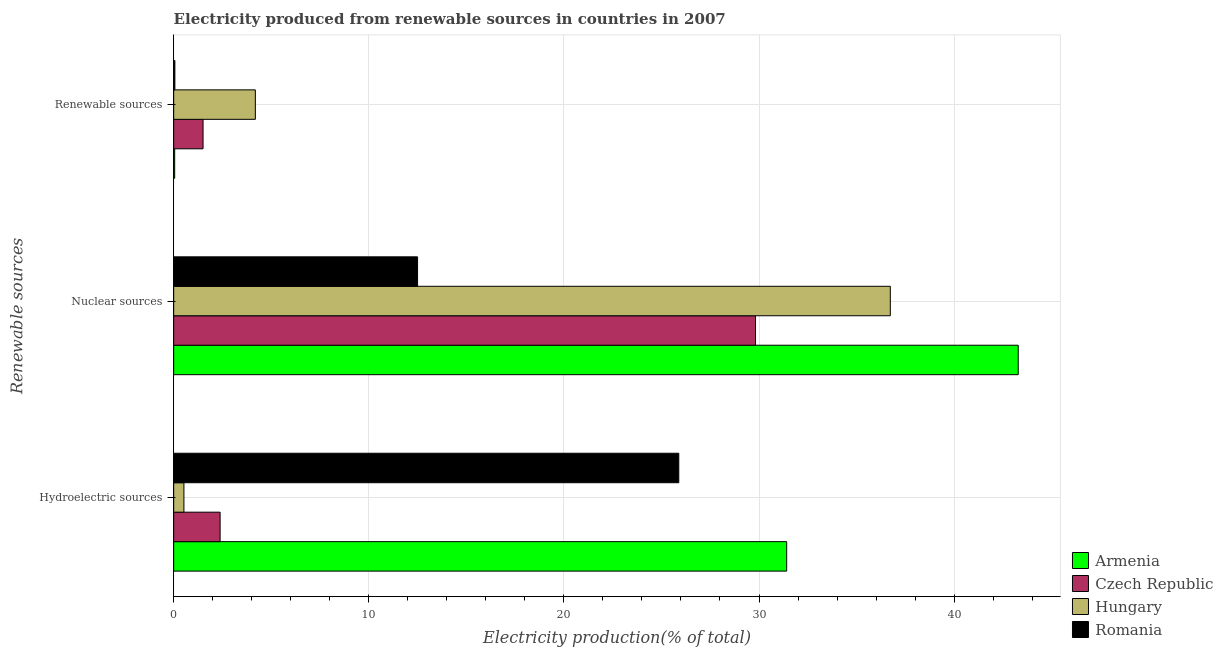How many different coloured bars are there?
Your answer should be compact. 4. How many groups of bars are there?
Your response must be concise. 3. Are the number of bars per tick equal to the number of legend labels?
Ensure brevity in your answer.  Yes. How many bars are there on the 2nd tick from the top?
Your answer should be compact. 4. What is the label of the 1st group of bars from the top?
Your response must be concise. Renewable sources. What is the percentage of electricity produced by renewable sources in Armenia?
Offer a terse response. 0.05. Across all countries, what is the maximum percentage of electricity produced by renewable sources?
Your answer should be very brief. 4.19. Across all countries, what is the minimum percentage of electricity produced by hydroelectric sources?
Your answer should be very brief. 0.53. In which country was the percentage of electricity produced by renewable sources maximum?
Offer a terse response. Hungary. In which country was the percentage of electricity produced by nuclear sources minimum?
Give a very brief answer. Romania. What is the total percentage of electricity produced by renewable sources in the graph?
Your answer should be very brief. 5.8. What is the difference between the percentage of electricity produced by renewable sources in Hungary and that in Romania?
Your answer should be compact. 4.13. What is the difference between the percentage of electricity produced by renewable sources in Romania and the percentage of electricity produced by hydroelectric sources in Armenia?
Keep it short and to the point. -31.36. What is the average percentage of electricity produced by renewable sources per country?
Ensure brevity in your answer.  1.45. What is the difference between the percentage of electricity produced by hydroelectric sources and percentage of electricity produced by nuclear sources in Armenia?
Your answer should be compact. -11.87. What is the ratio of the percentage of electricity produced by hydroelectric sources in Hungary to that in Czech Republic?
Your response must be concise. 0.22. Is the percentage of electricity produced by nuclear sources in Armenia less than that in Hungary?
Offer a terse response. No. Is the difference between the percentage of electricity produced by nuclear sources in Hungary and Armenia greater than the difference between the percentage of electricity produced by hydroelectric sources in Hungary and Armenia?
Your answer should be compact. Yes. What is the difference between the highest and the second highest percentage of electricity produced by nuclear sources?
Make the answer very short. 6.56. What is the difference between the highest and the lowest percentage of electricity produced by renewable sources?
Offer a terse response. 4.14. What does the 2nd bar from the top in Renewable sources represents?
Keep it short and to the point. Hungary. What does the 2nd bar from the bottom in Renewable sources represents?
Offer a terse response. Czech Republic. Is it the case that in every country, the sum of the percentage of electricity produced by hydroelectric sources and percentage of electricity produced by nuclear sources is greater than the percentage of electricity produced by renewable sources?
Offer a terse response. Yes. How many bars are there?
Provide a succinct answer. 12. Are all the bars in the graph horizontal?
Keep it short and to the point. Yes. Are the values on the major ticks of X-axis written in scientific E-notation?
Your answer should be very brief. No. Does the graph contain grids?
Your answer should be very brief. Yes. Where does the legend appear in the graph?
Make the answer very short. Bottom right. How many legend labels are there?
Your response must be concise. 4. How are the legend labels stacked?
Provide a short and direct response. Vertical. What is the title of the graph?
Make the answer very short. Electricity produced from renewable sources in countries in 2007. Does "Bhutan" appear as one of the legend labels in the graph?
Provide a succinct answer. No. What is the label or title of the X-axis?
Offer a very short reply. Electricity production(% of total). What is the label or title of the Y-axis?
Your answer should be very brief. Renewable sources. What is the Electricity production(% of total) of Armenia in Hydroelectric sources?
Ensure brevity in your answer.  31.42. What is the Electricity production(% of total) in Czech Republic in Hydroelectric sources?
Offer a very short reply. 2.38. What is the Electricity production(% of total) of Hungary in Hydroelectric sources?
Your answer should be very brief. 0.53. What is the Electricity production(% of total) in Romania in Hydroelectric sources?
Give a very brief answer. 25.89. What is the Electricity production(% of total) in Armenia in Nuclear sources?
Keep it short and to the point. 43.29. What is the Electricity production(% of total) in Czech Republic in Nuclear sources?
Give a very brief answer. 29.82. What is the Electricity production(% of total) of Hungary in Nuclear sources?
Your response must be concise. 36.73. What is the Electricity production(% of total) of Romania in Nuclear sources?
Offer a terse response. 12.5. What is the Electricity production(% of total) of Armenia in Renewable sources?
Offer a terse response. 0.05. What is the Electricity production(% of total) of Czech Republic in Renewable sources?
Provide a short and direct response. 1.51. What is the Electricity production(% of total) in Hungary in Renewable sources?
Your response must be concise. 4.19. What is the Electricity production(% of total) of Romania in Renewable sources?
Your answer should be compact. 0.06. Across all Renewable sources, what is the maximum Electricity production(% of total) in Armenia?
Make the answer very short. 43.29. Across all Renewable sources, what is the maximum Electricity production(% of total) in Czech Republic?
Ensure brevity in your answer.  29.82. Across all Renewable sources, what is the maximum Electricity production(% of total) of Hungary?
Your answer should be compact. 36.73. Across all Renewable sources, what is the maximum Electricity production(% of total) in Romania?
Keep it short and to the point. 25.89. Across all Renewable sources, what is the minimum Electricity production(% of total) in Armenia?
Ensure brevity in your answer.  0.05. Across all Renewable sources, what is the minimum Electricity production(% of total) in Czech Republic?
Offer a very short reply. 1.51. Across all Renewable sources, what is the minimum Electricity production(% of total) of Hungary?
Ensure brevity in your answer.  0.53. Across all Renewable sources, what is the minimum Electricity production(% of total) of Romania?
Your response must be concise. 0.06. What is the total Electricity production(% of total) of Armenia in the graph?
Provide a short and direct response. 74.75. What is the total Electricity production(% of total) in Czech Republic in the graph?
Offer a very short reply. 33.71. What is the total Electricity production(% of total) of Hungary in the graph?
Offer a terse response. 41.44. What is the total Electricity production(% of total) of Romania in the graph?
Offer a very short reply. 38.45. What is the difference between the Electricity production(% of total) in Armenia in Hydroelectric sources and that in Nuclear sources?
Offer a terse response. -11.87. What is the difference between the Electricity production(% of total) of Czech Republic in Hydroelectric sources and that in Nuclear sources?
Provide a short and direct response. -27.44. What is the difference between the Electricity production(% of total) in Hungary in Hydroelectric sources and that in Nuclear sources?
Offer a very short reply. -36.2. What is the difference between the Electricity production(% of total) in Romania in Hydroelectric sources and that in Nuclear sources?
Make the answer very short. 13.39. What is the difference between the Electricity production(% of total) of Armenia in Hydroelectric sources and that in Renewable sources?
Keep it short and to the point. 31.37. What is the difference between the Electricity production(% of total) of Czech Republic in Hydroelectric sources and that in Renewable sources?
Provide a succinct answer. 0.88. What is the difference between the Electricity production(% of total) of Hungary in Hydroelectric sources and that in Renewable sources?
Your response must be concise. -3.66. What is the difference between the Electricity production(% of total) of Romania in Hydroelectric sources and that in Renewable sources?
Provide a succinct answer. 25.83. What is the difference between the Electricity production(% of total) of Armenia in Nuclear sources and that in Renewable sources?
Ensure brevity in your answer.  43.23. What is the difference between the Electricity production(% of total) of Czech Republic in Nuclear sources and that in Renewable sources?
Provide a short and direct response. 28.32. What is the difference between the Electricity production(% of total) in Hungary in Nuclear sources and that in Renewable sources?
Keep it short and to the point. 32.54. What is the difference between the Electricity production(% of total) in Romania in Nuclear sources and that in Renewable sources?
Offer a very short reply. 12.44. What is the difference between the Electricity production(% of total) in Armenia in Hydroelectric sources and the Electricity production(% of total) in Czech Republic in Nuclear sources?
Offer a very short reply. 1.6. What is the difference between the Electricity production(% of total) of Armenia in Hydroelectric sources and the Electricity production(% of total) of Hungary in Nuclear sources?
Offer a very short reply. -5.31. What is the difference between the Electricity production(% of total) of Armenia in Hydroelectric sources and the Electricity production(% of total) of Romania in Nuclear sources?
Provide a succinct answer. 18.92. What is the difference between the Electricity production(% of total) in Czech Republic in Hydroelectric sources and the Electricity production(% of total) in Hungary in Nuclear sources?
Provide a succinct answer. -34.35. What is the difference between the Electricity production(% of total) of Czech Republic in Hydroelectric sources and the Electricity production(% of total) of Romania in Nuclear sources?
Your answer should be compact. -10.12. What is the difference between the Electricity production(% of total) of Hungary in Hydroelectric sources and the Electricity production(% of total) of Romania in Nuclear sources?
Ensure brevity in your answer.  -11.97. What is the difference between the Electricity production(% of total) of Armenia in Hydroelectric sources and the Electricity production(% of total) of Czech Republic in Renewable sources?
Your answer should be compact. 29.91. What is the difference between the Electricity production(% of total) of Armenia in Hydroelectric sources and the Electricity production(% of total) of Hungary in Renewable sources?
Provide a succinct answer. 27.23. What is the difference between the Electricity production(% of total) of Armenia in Hydroelectric sources and the Electricity production(% of total) of Romania in Renewable sources?
Make the answer very short. 31.36. What is the difference between the Electricity production(% of total) of Czech Republic in Hydroelectric sources and the Electricity production(% of total) of Hungary in Renewable sources?
Give a very brief answer. -1.81. What is the difference between the Electricity production(% of total) of Czech Republic in Hydroelectric sources and the Electricity production(% of total) of Romania in Renewable sources?
Provide a short and direct response. 2.32. What is the difference between the Electricity production(% of total) in Hungary in Hydroelectric sources and the Electricity production(% of total) in Romania in Renewable sources?
Offer a terse response. 0.46. What is the difference between the Electricity production(% of total) of Armenia in Nuclear sources and the Electricity production(% of total) of Czech Republic in Renewable sources?
Keep it short and to the point. 41.78. What is the difference between the Electricity production(% of total) of Armenia in Nuclear sources and the Electricity production(% of total) of Hungary in Renewable sources?
Make the answer very short. 39.1. What is the difference between the Electricity production(% of total) of Armenia in Nuclear sources and the Electricity production(% of total) of Romania in Renewable sources?
Keep it short and to the point. 43.22. What is the difference between the Electricity production(% of total) of Czech Republic in Nuclear sources and the Electricity production(% of total) of Hungary in Renewable sources?
Keep it short and to the point. 25.63. What is the difference between the Electricity production(% of total) in Czech Republic in Nuclear sources and the Electricity production(% of total) in Romania in Renewable sources?
Offer a very short reply. 29.76. What is the difference between the Electricity production(% of total) in Hungary in Nuclear sources and the Electricity production(% of total) in Romania in Renewable sources?
Offer a terse response. 36.67. What is the average Electricity production(% of total) of Armenia per Renewable sources?
Your response must be concise. 24.92. What is the average Electricity production(% of total) in Czech Republic per Renewable sources?
Your answer should be very brief. 11.24. What is the average Electricity production(% of total) in Hungary per Renewable sources?
Give a very brief answer. 13.81. What is the average Electricity production(% of total) in Romania per Renewable sources?
Offer a very short reply. 12.82. What is the difference between the Electricity production(% of total) in Armenia and Electricity production(% of total) in Czech Republic in Hydroelectric sources?
Ensure brevity in your answer.  29.04. What is the difference between the Electricity production(% of total) in Armenia and Electricity production(% of total) in Hungary in Hydroelectric sources?
Offer a very short reply. 30.89. What is the difference between the Electricity production(% of total) in Armenia and Electricity production(% of total) in Romania in Hydroelectric sources?
Give a very brief answer. 5.53. What is the difference between the Electricity production(% of total) of Czech Republic and Electricity production(% of total) of Hungary in Hydroelectric sources?
Your response must be concise. 1.85. What is the difference between the Electricity production(% of total) of Czech Republic and Electricity production(% of total) of Romania in Hydroelectric sources?
Ensure brevity in your answer.  -23.51. What is the difference between the Electricity production(% of total) of Hungary and Electricity production(% of total) of Romania in Hydroelectric sources?
Your response must be concise. -25.36. What is the difference between the Electricity production(% of total) in Armenia and Electricity production(% of total) in Czech Republic in Nuclear sources?
Keep it short and to the point. 13.46. What is the difference between the Electricity production(% of total) in Armenia and Electricity production(% of total) in Hungary in Nuclear sources?
Give a very brief answer. 6.56. What is the difference between the Electricity production(% of total) of Armenia and Electricity production(% of total) of Romania in Nuclear sources?
Keep it short and to the point. 30.79. What is the difference between the Electricity production(% of total) in Czech Republic and Electricity production(% of total) in Hungary in Nuclear sources?
Your answer should be very brief. -6.91. What is the difference between the Electricity production(% of total) of Czech Republic and Electricity production(% of total) of Romania in Nuclear sources?
Offer a terse response. 17.32. What is the difference between the Electricity production(% of total) in Hungary and Electricity production(% of total) in Romania in Nuclear sources?
Offer a terse response. 24.23. What is the difference between the Electricity production(% of total) in Armenia and Electricity production(% of total) in Czech Republic in Renewable sources?
Offer a very short reply. -1.45. What is the difference between the Electricity production(% of total) in Armenia and Electricity production(% of total) in Hungary in Renewable sources?
Provide a succinct answer. -4.14. What is the difference between the Electricity production(% of total) of Armenia and Electricity production(% of total) of Romania in Renewable sources?
Keep it short and to the point. -0.01. What is the difference between the Electricity production(% of total) in Czech Republic and Electricity production(% of total) in Hungary in Renewable sources?
Make the answer very short. -2.68. What is the difference between the Electricity production(% of total) of Czech Republic and Electricity production(% of total) of Romania in Renewable sources?
Your answer should be very brief. 1.44. What is the difference between the Electricity production(% of total) of Hungary and Electricity production(% of total) of Romania in Renewable sources?
Keep it short and to the point. 4.13. What is the ratio of the Electricity production(% of total) of Armenia in Hydroelectric sources to that in Nuclear sources?
Offer a very short reply. 0.73. What is the ratio of the Electricity production(% of total) in Czech Republic in Hydroelectric sources to that in Nuclear sources?
Offer a very short reply. 0.08. What is the ratio of the Electricity production(% of total) of Hungary in Hydroelectric sources to that in Nuclear sources?
Ensure brevity in your answer.  0.01. What is the ratio of the Electricity production(% of total) of Romania in Hydroelectric sources to that in Nuclear sources?
Offer a very short reply. 2.07. What is the ratio of the Electricity production(% of total) in Armenia in Hydroelectric sources to that in Renewable sources?
Your answer should be compact. 617.67. What is the ratio of the Electricity production(% of total) in Czech Republic in Hydroelectric sources to that in Renewable sources?
Your answer should be compact. 1.58. What is the ratio of the Electricity production(% of total) in Hungary in Hydroelectric sources to that in Renewable sources?
Your answer should be compact. 0.13. What is the ratio of the Electricity production(% of total) of Romania in Hydroelectric sources to that in Renewable sources?
Keep it short and to the point. 420.16. What is the ratio of the Electricity production(% of total) of Armenia in Nuclear sources to that in Renewable sources?
Offer a very short reply. 851. What is the ratio of the Electricity production(% of total) of Czech Republic in Nuclear sources to that in Renewable sources?
Provide a short and direct response. 19.81. What is the ratio of the Electricity production(% of total) in Hungary in Nuclear sources to that in Renewable sources?
Offer a terse response. 8.77. What is the ratio of the Electricity production(% of total) of Romania in Nuclear sources to that in Renewable sources?
Your answer should be compact. 202.87. What is the difference between the highest and the second highest Electricity production(% of total) in Armenia?
Offer a very short reply. 11.87. What is the difference between the highest and the second highest Electricity production(% of total) in Czech Republic?
Your answer should be very brief. 27.44. What is the difference between the highest and the second highest Electricity production(% of total) of Hungary?
Give a very brief answer. 32.54. What is the difference between the highest and the second highest Electricity production(% of total) in Romania?
Offer a terse response. 13.39. What is the difference between the highest and the lowest Electricity production(% of total) of Armenia?
Your answer should be very brief. 43.23. What is the difference between the highest and the lowest Electricity production(% of total) of Czech Republic?
Your answer should be compact. 28.32. What is the difference between the highest and the lowest Electricity production(% of total) of Hungary?
Offer a terse response. 36.2. What is the difference between the highest and the lowest Electricity production(% of total) in Romania?
Provide a short and direct response. 25.83. 